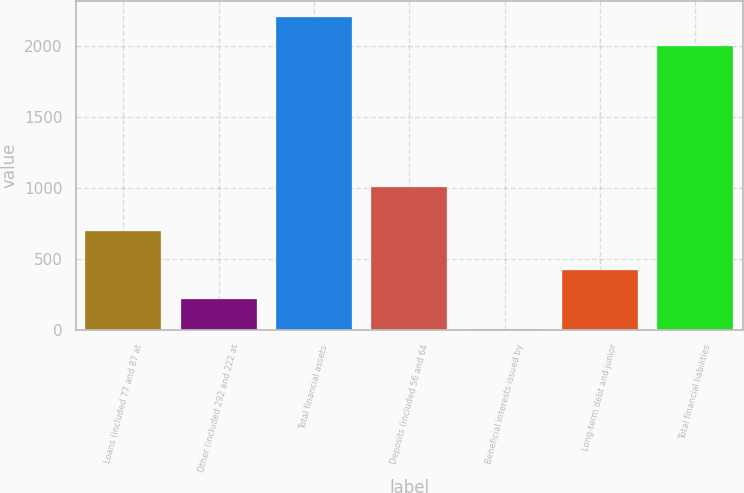<chart> <loc_0><loc_0><loc_500><loc_500><bar_chart><fcel>Loans (included 77 and 87 at<fcel>Other (included 292 and 222 at<fcel>Total financial assets<fcel>Deposits (included 56 and 64<fcel>Beneficial interests issued by<fcel>Long-term debt and junior<fcel>Total financial liabilities<nl><fcel>700<fcel>217.76<fcel>2204.66<fcel>1010.2<fcel>10.5<fcel>425.02<fcel>1997.4<nl></chart> 